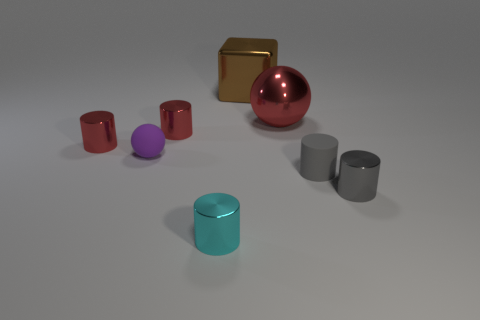What material is the tiny thing that is the same color as the tiny matte cylinder?
Offer a very short reply. Metal. There is a red ball that is the same size as the brown block; what is it made of?
Your answer should be compact. Metal. How many small shiny cylinders are on the right side of the small matte cylinder?
Offer a very short reply. 1. Is the red cylinder that is right of the small purple thing made of the same material as the red thing on the left side of the purple object?
Your answer should be very brief. Yes. What is the shape of the tiny rubber thing that is on the right side of the red shiny cylinder that is right of the red metallic object on the left side of the purple ball?
Provide a succinct answer. Cylinder. The tiny purple object is what shape?
Your response must be concise. Sphere. What is the shape of the gray rubber thing that is the same size as the cyan metal cylinder?
Your answer should be very brief. Cylinder. What number of other things are the same color as the large ball?
Provide a succinct answer. 2. There is a large metal thing that is to the right of the large block; does it have the same shape as the metallic object to the right of the tiny gray rubber cylinder?
Give a very brief answer. No. What number of objects are tiny cylinders that are left of the small cyan cylinder or things that are left of the metallic cube?
Ensure brevity in your answer.  4. 